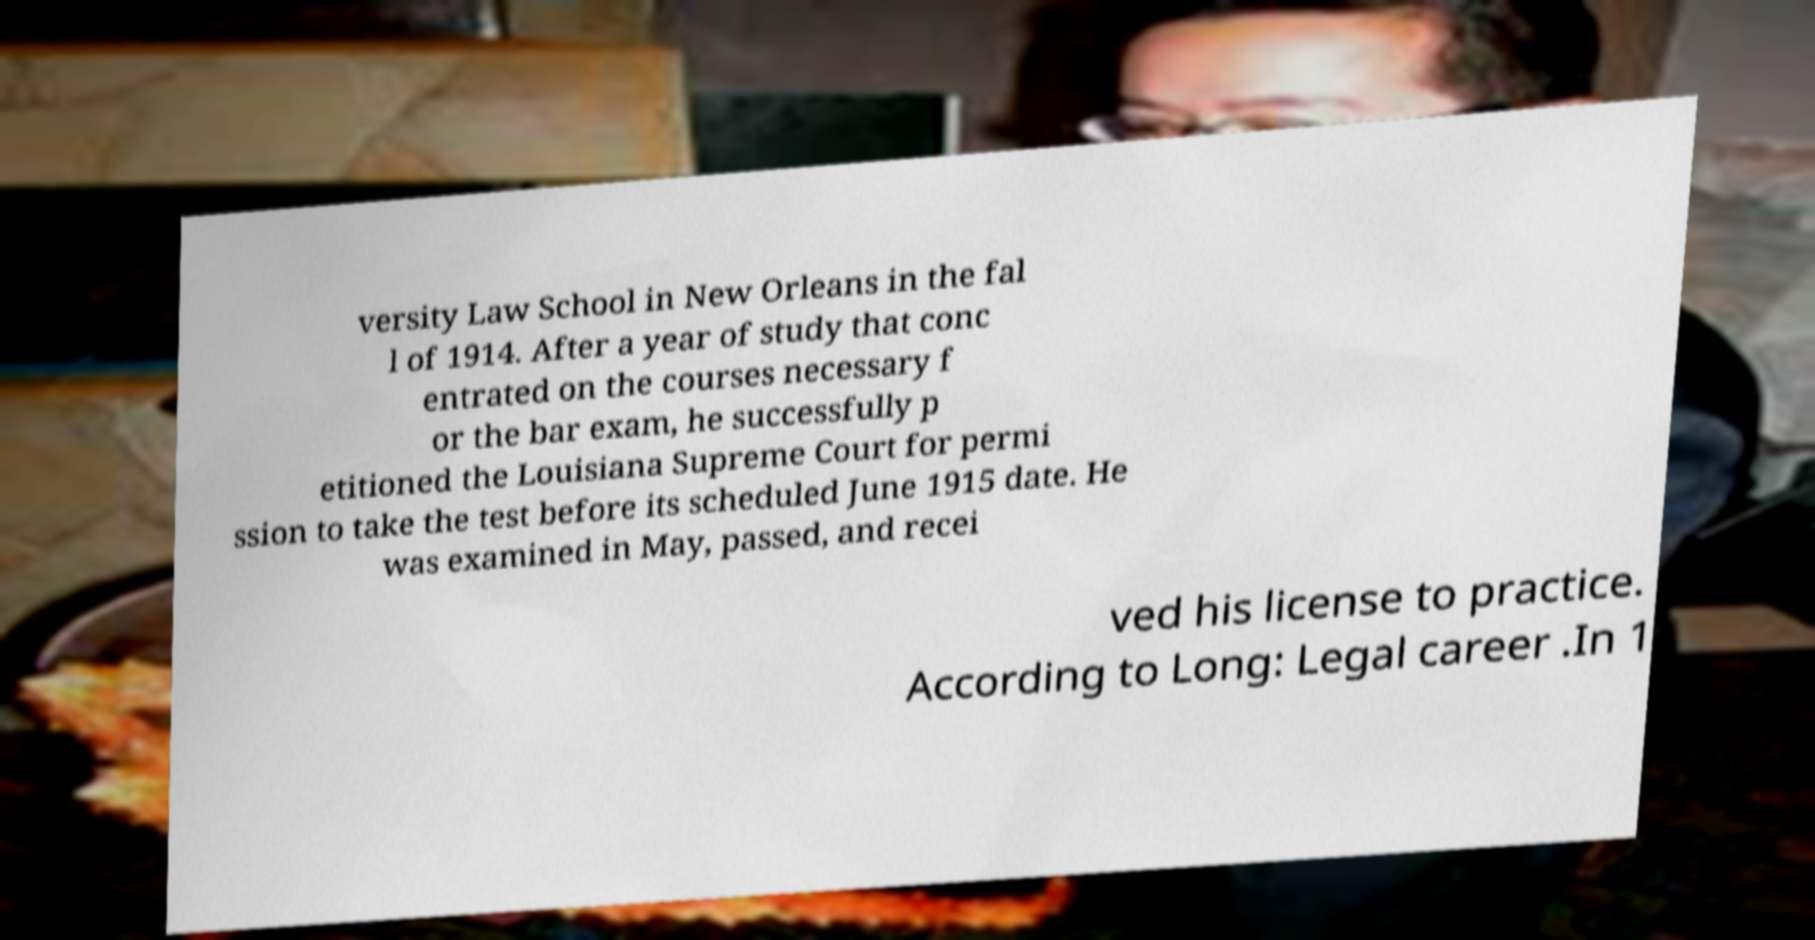Please identify and transcribe the text found in this image. versity Law School in New Orleans in the fal l of 1914. After a year of study that conc entrated on the courses necessary f or the bar exam, he successfully p etitioned the Louisiana Supreme Court for permi ssion to take the test before its scheduled June 1915 date. He was examined in May, passed, and recei ved his license to practice. According to Long: Legal career .In 1 